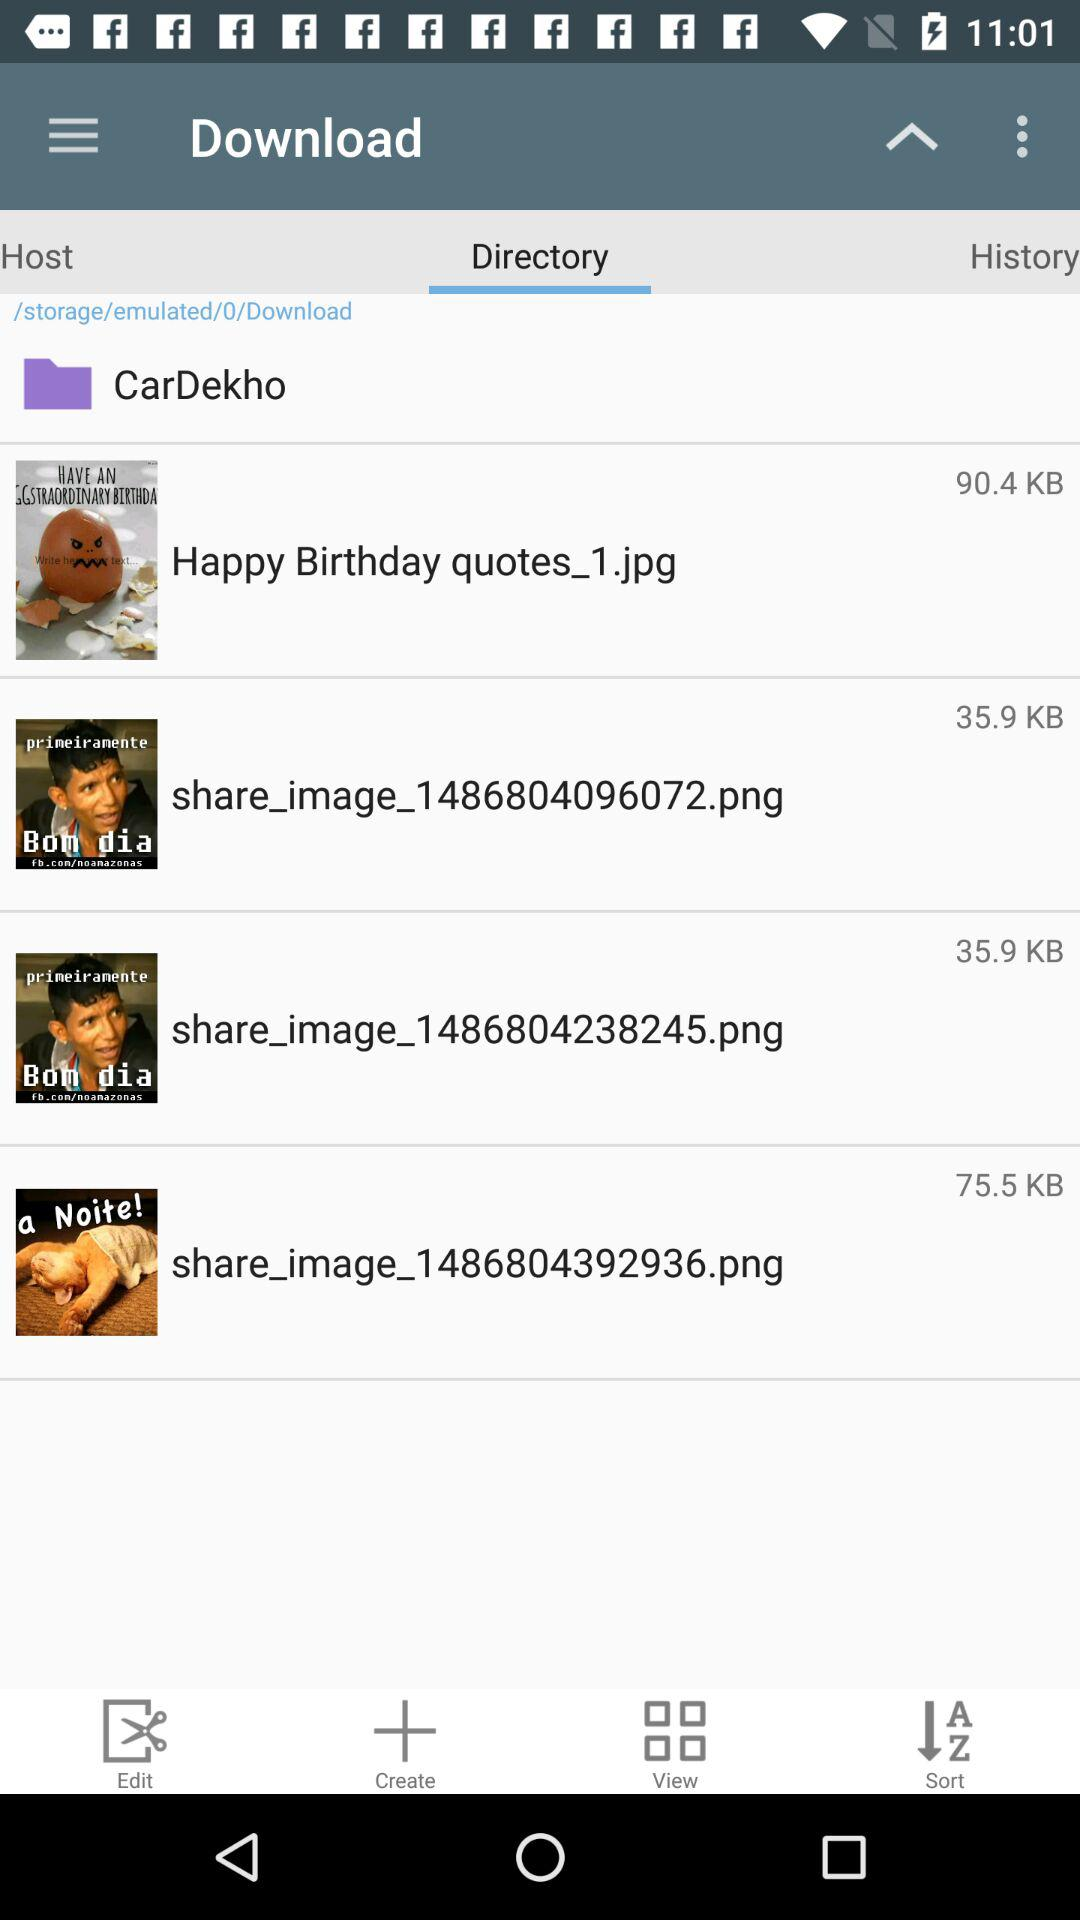How many KB is the largest file in the download folder?
Answer the question using a single word or phrase. 90.4 KB 